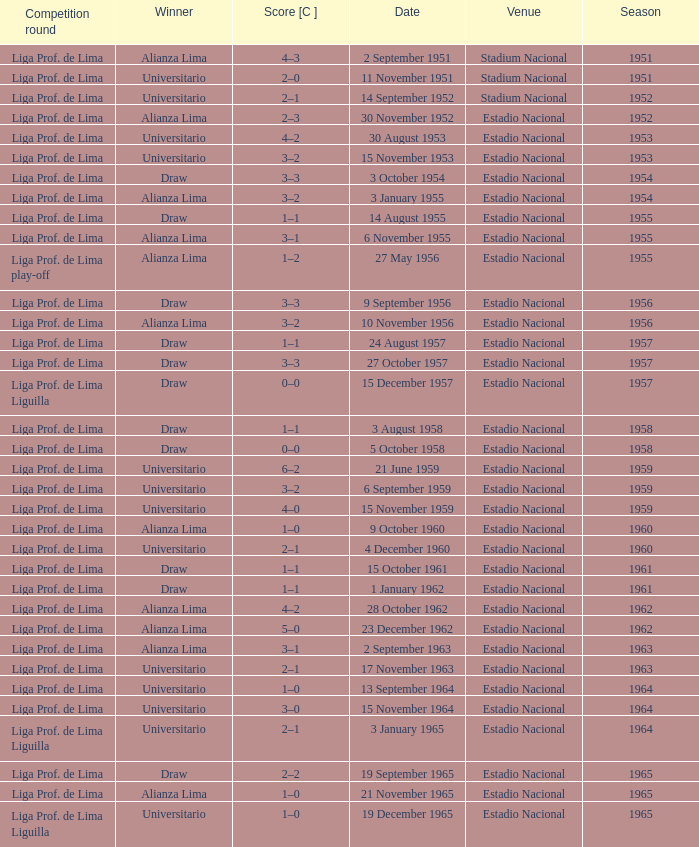What venue had an event on 17 November 1963? Estadio Nacional. 